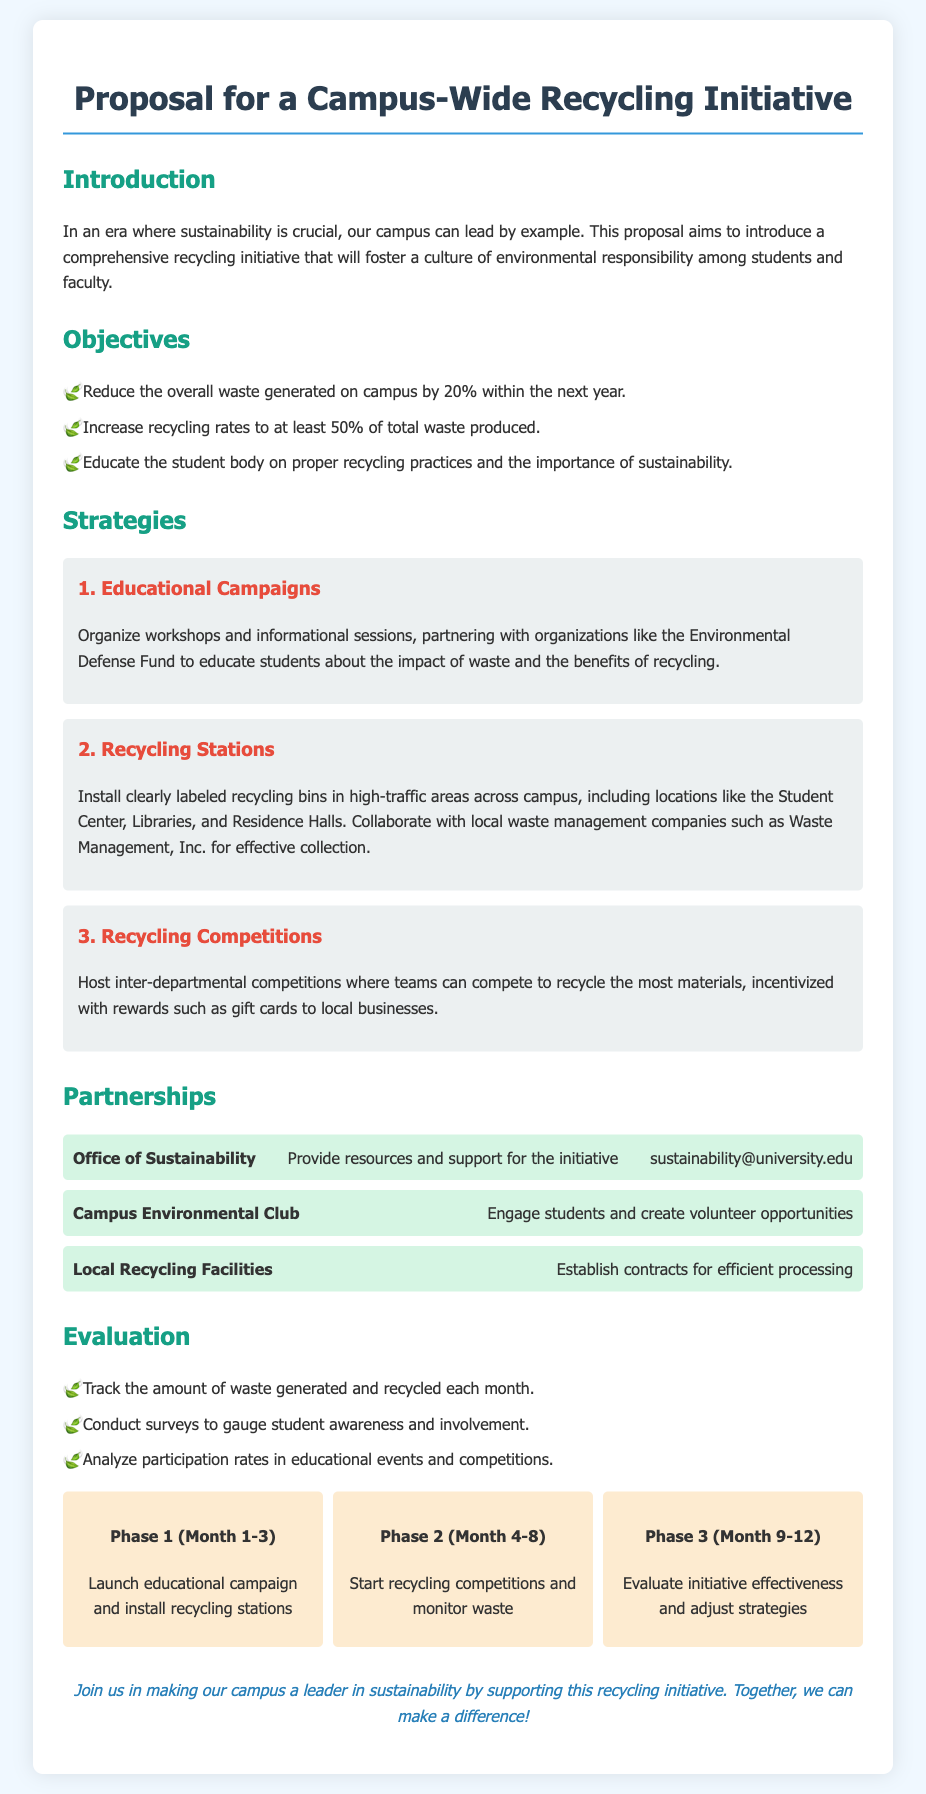what is the goal for reducing waste on campus? The document states the objective of reducing overall waste generated on campus by 20% within the next year.
Answer: 20% what percentage of total waste does the proposal aim to recycle? The initiative aims to increase recycling rates to at least 50% of total waste produced.
Answer: 50% which organization is suggested to partner for educational campaigns? The proposal mentions partnering with the Environmental Defense Fund to educate students about the impact of waste.
Answer: Environmental Defense Fund how many phases are there in the timeline? The timeline in the document consists of three distinct phases for the initiative implementation.
Answer: 3 what is the intended outcome of the recycling competitions? The document states that the competitions will incentivize recycling among teams, rewarding them to encourage participation.
Answer: rewards which group is responsible for providing resources and support for the initiative? The Office of Sustainability is highlighted as the group that will provide resources and support for the recycling initiative.
Answer: Office of Sustainability what is the main focus of Phase 2 in the timeline? Phase 2 focuses on starting recycling competitions and monitoring waste generated on campus.
Answer: recycling competitions how will the initiative assess student involvement? The initiative will conduct surveys to gauge student awareness and involvement, which is part of the evaluation plan.
Answer: surveys what will be installed in high-traffic areas as part of the initiative? The proposal includes installing clearly labeled recycling bins in high-traffic areas across campus.
Answer: recycling bins what is the conclusion encouraging students to do? The conclusion invites students to join in making the campus a leader in sustainability by supporting the recycling initiative.
Answer: support the initiative 